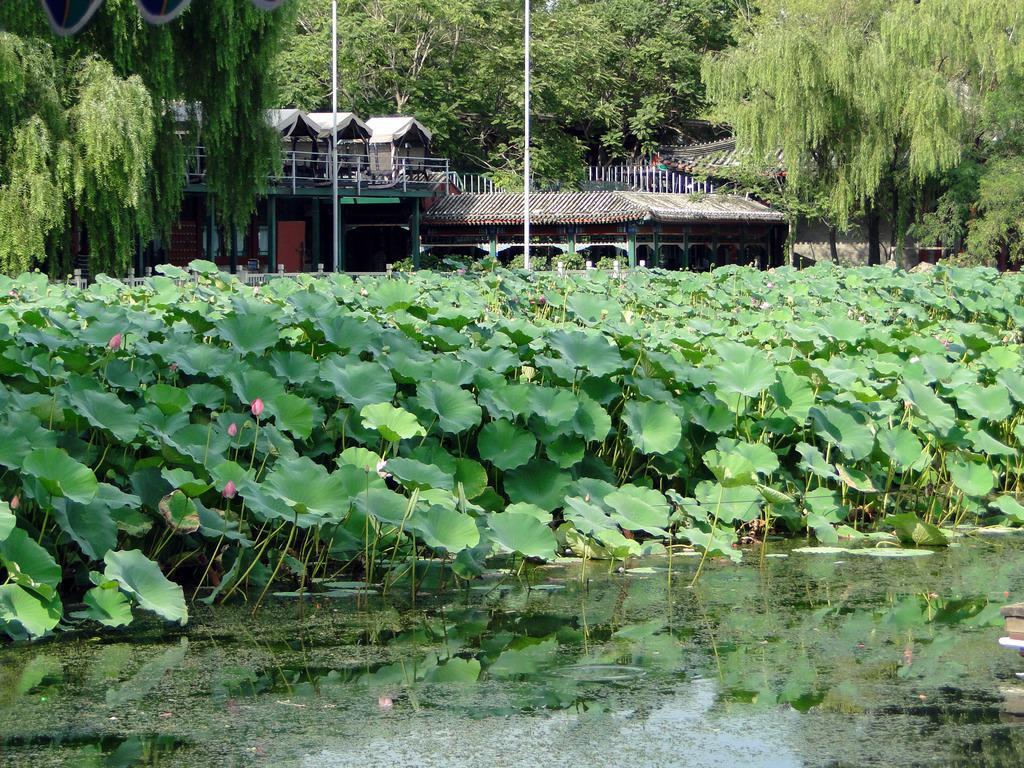Describe this image in one or two sentences. In this image, there are a few houses, poles, trees, plants. We can also see some water and the fence. We can also see some objects on the right. 